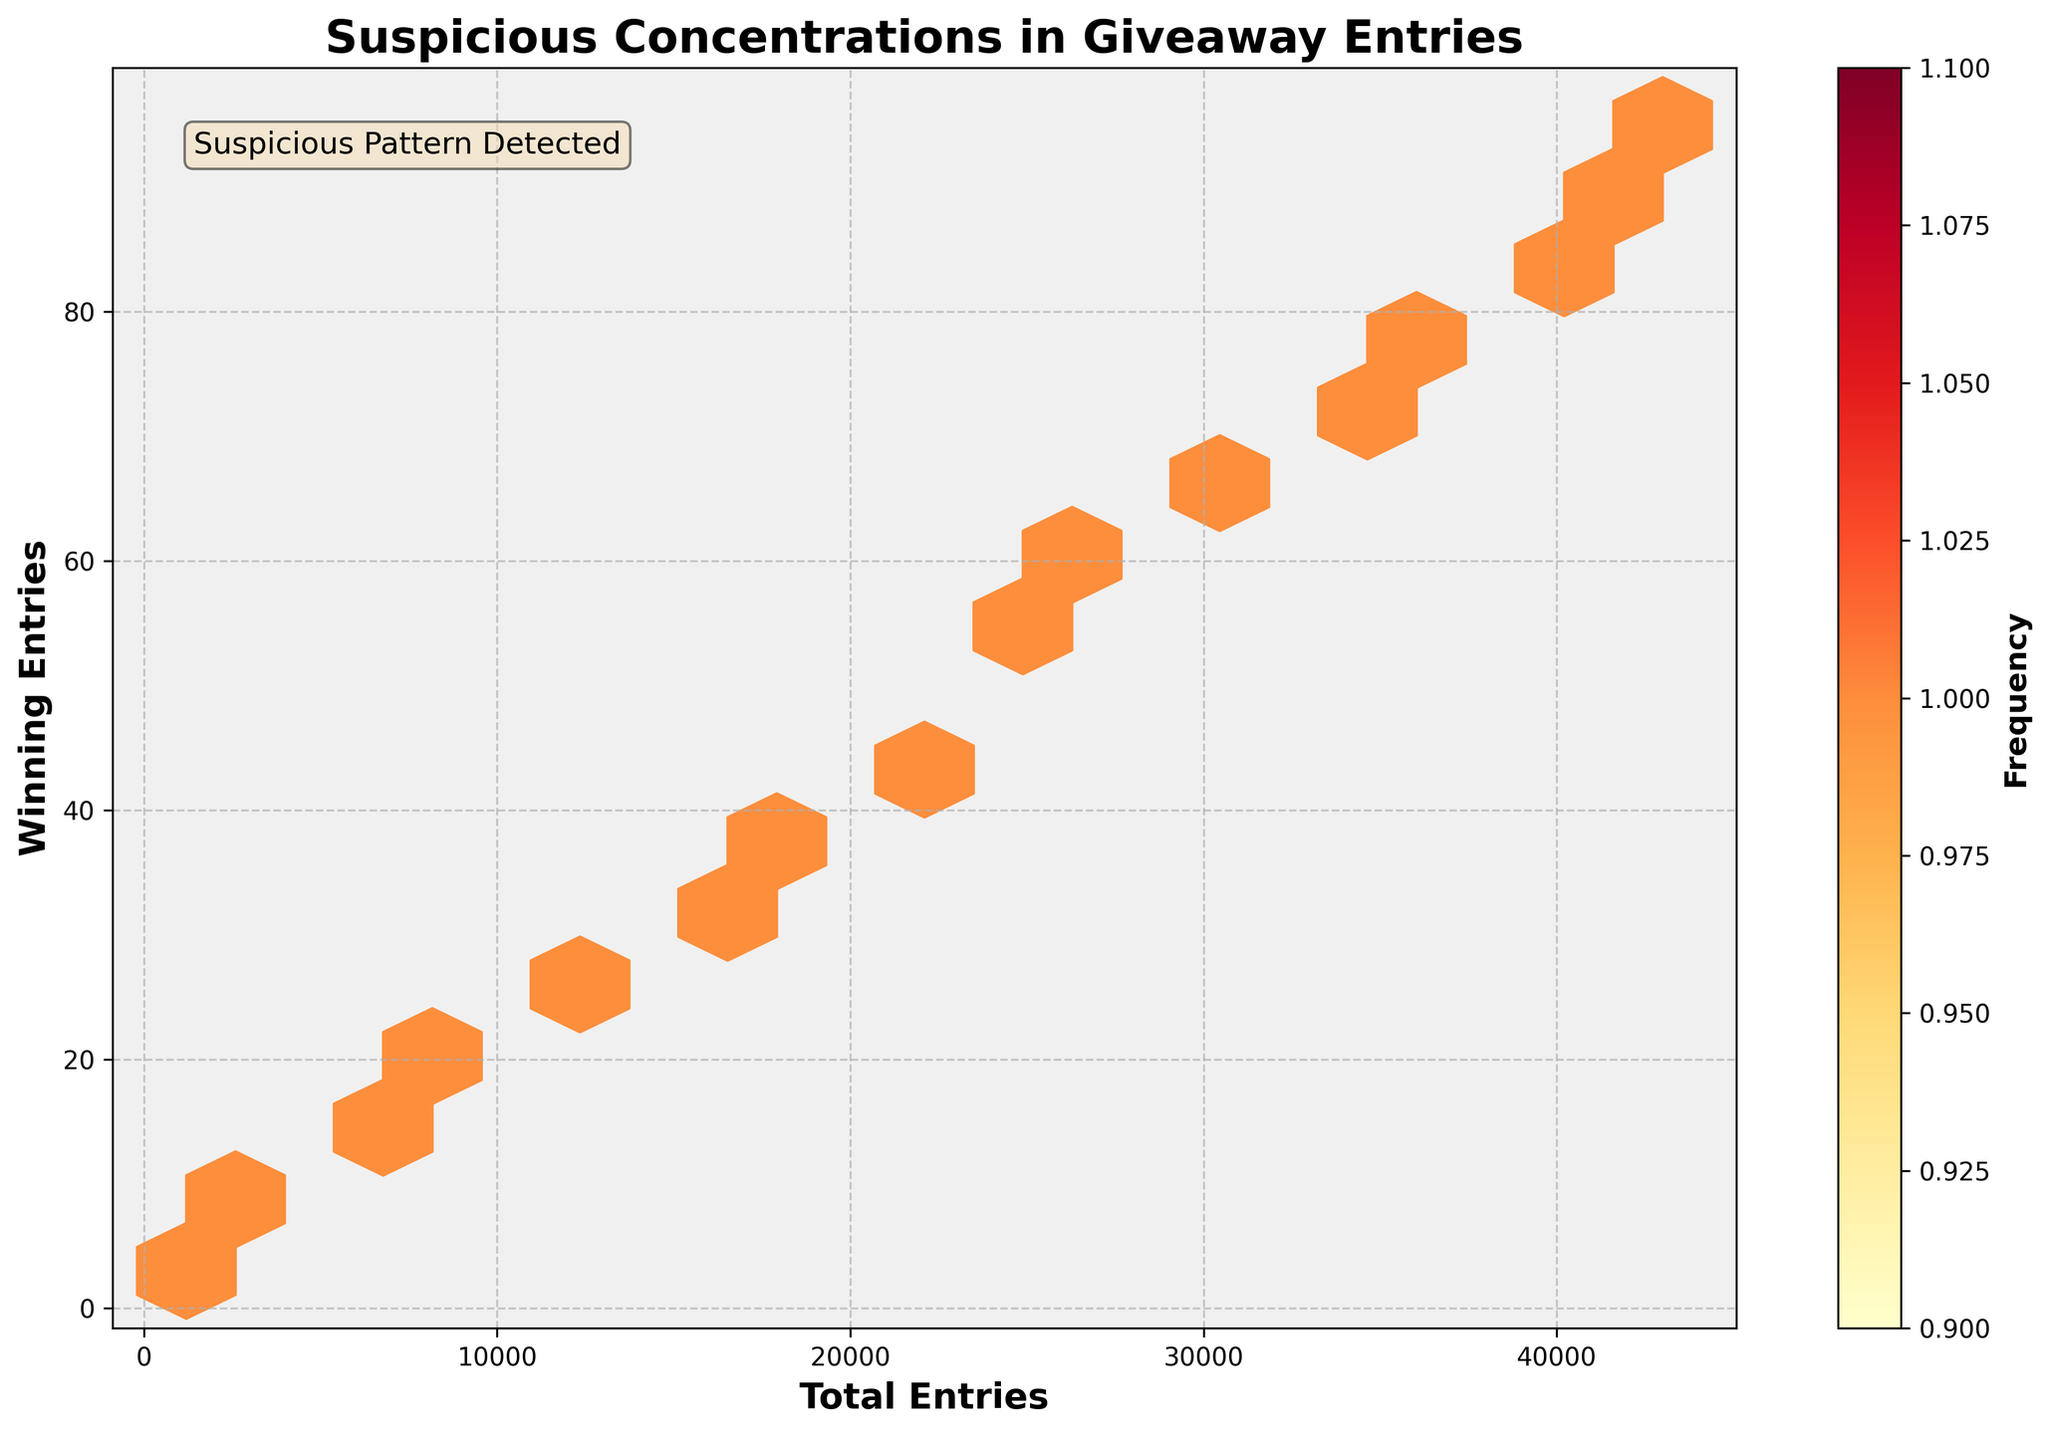What is the title of the Hexbin Plot? The title is usually found at the top part of the plot and it provides a brief description of what the plot is about.
Answer: Suspicious Concentrations in Giveaway Entries How are the axes labeled? The labels of the axes provide context for what the x and y coordinates represent. By looking at the labels, we understand that the horizontal axis shows 'Total Entries' and the vertical axis shows 'Winning Entries'.
Answer: 'Total Entries' and 'Winning Entries' What does the color bar represent in the Hexbin plot? The color bar, usually on the side of the plot, indicates the frequency of points within each hexagon. The given label on the color bar reveals that it represents 'Frequency'.
Answer: Frequency Which area(s) in the plot show a higher frequency of points? By interpreting the intensity of the color, we can identify areas with the densest concentrations of points. The area with the deepest color (often red in the given colormap 'YlOrRd') shows the highest frequency.
Answer: Areas with the deepest red color Where do you find the highest concentration of winning entries? The area with the highest concentration of winning entries is marked by the darkest red color in the vertical direction.
Answer: Close to Total Entries around 36000 to 42000 Are there more winning entries earlier (left side) or later (right side) in the 'Total Entries'? Observing the color density from the left side toward the right, we notice that the darker hexagons are predominately on the right side, indicating more winning entries later.
Answer: Later (right side) What pattern is indicated by the text annotation in the plot? The text annotation provides a clue or significant point about the plot. It states that there is a 'Suspicious Pattern Detected', hinting to viewers that there is something unusual about the data distribution.
Answer: Suspicious Pattern Detected Is there a proportional relationship between total entries and winning entries based on color distribution? By looking at the gradation of color from the bottom left to the upper right, we can determine if a proportional relationship is suggested. In this case, darker colors trailing from lower-left to upper-right suggest a proportional relationship.
Answer: Yes What is the count of entries with approximately 21000 total and 45 winning entries? Find the hexagon closest to these coordinates and match the color with the frequency bar to estimate the count. The hexagon near (21000, 45) has a color indicating it has more than one count, based on the color map.
Answer: More than 1 Does the grid setup (15, cmap='YlOrRd') better reveal concentrations than a simpler scatter plot? Hexbin plots cluster data points into hexagons, helping to reveal density and concentrations with the help of color gradations, making it easier to observe patterns than simple scatter plots, especially for high-density areas.
Answer: Yes 